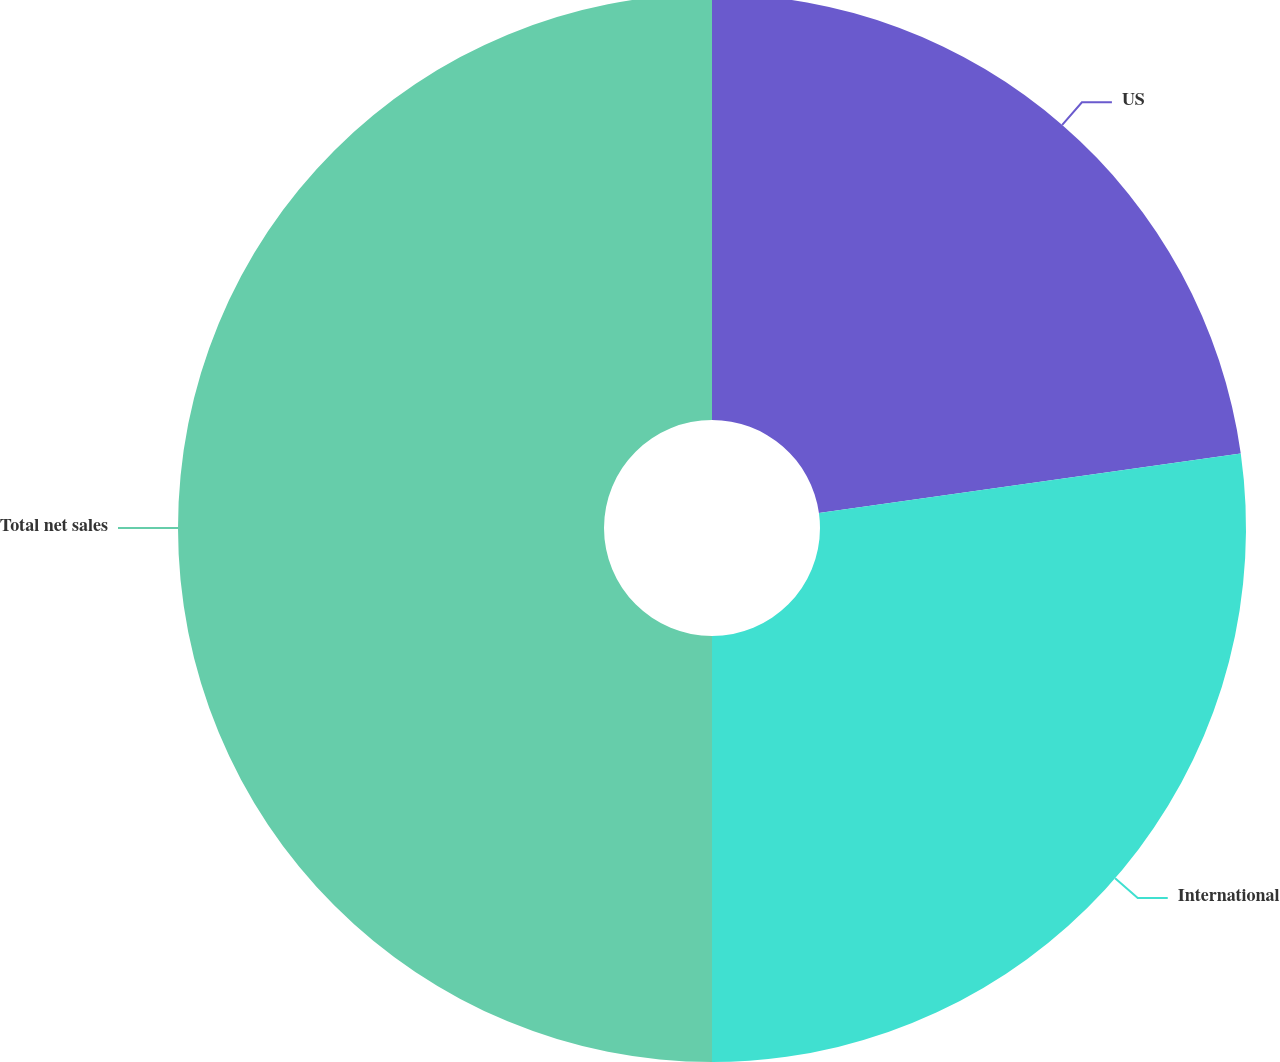Convert chart to OTSL. <chart><loc_0><loc_0><loc_500><loc_500><pie_chart><fcel>US<fcel>International<fcel>Total net sales<nl><fcel>22.77%<fcel>27.23%<fcel>50.0%<nl></chart> 